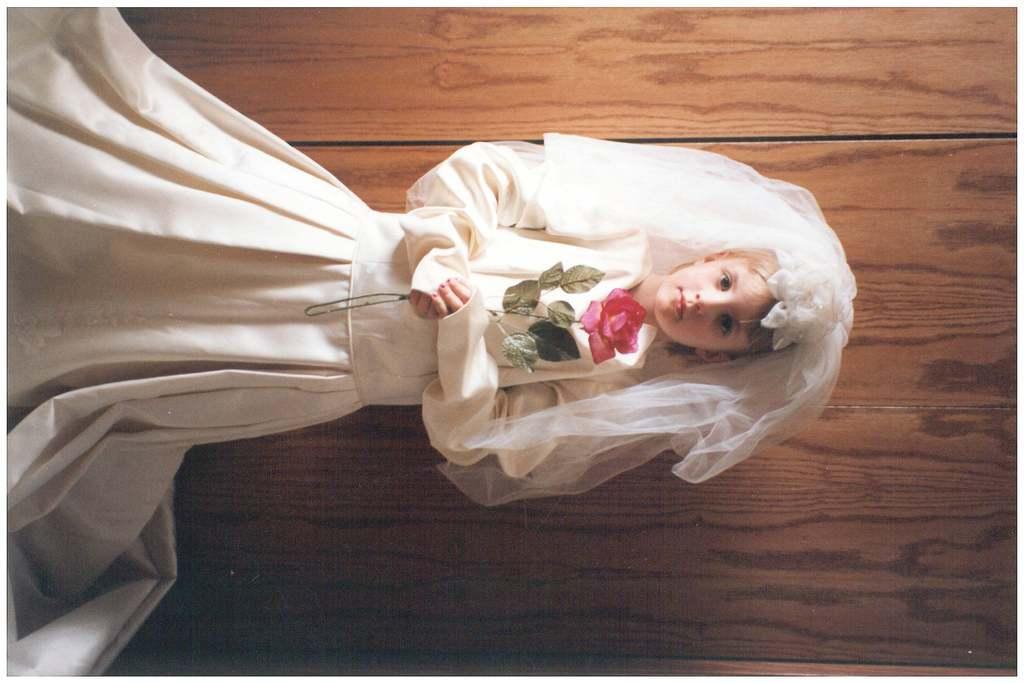In one or two sentences, can you explain what this image depicts? In the picture I can see a girl wearing the wedding dress and she is holding a flower in her hands. I can see the wooden wall. 